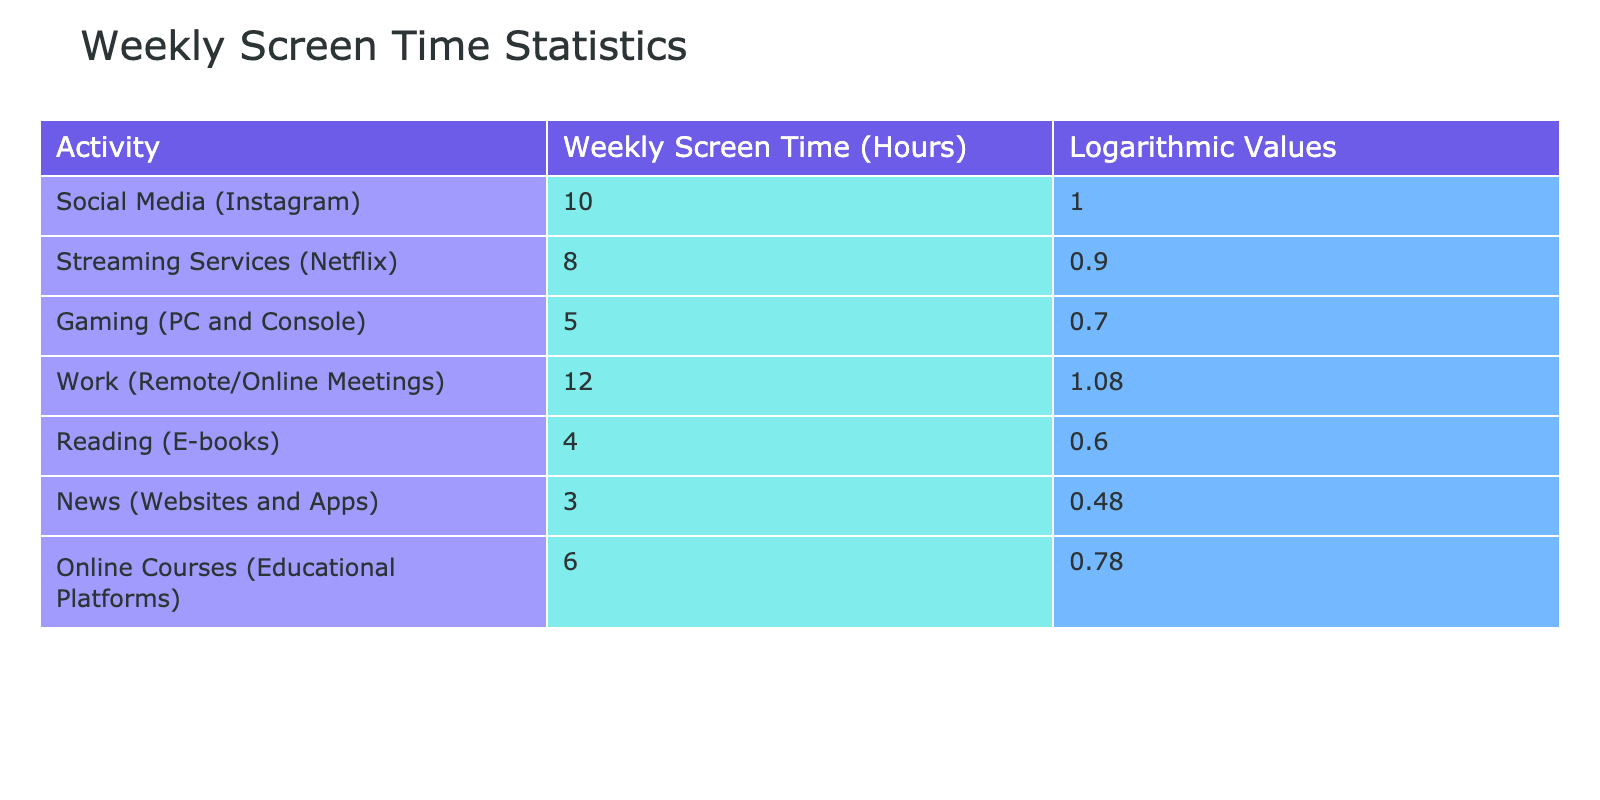What is the weekly screen time for Social Media (Instagram)? The table shows a specific value for each activity, and for Social Media (Instagram), the value listed is 10 hours.
Answer: 10 hours What is the logarithmic value for Streaming Services (Netflix)? By checking the table under the logarithmic values column, we can see that the value listed for Streaming Services (Netflix) is 0.90.
Answer: 0.90 Which activity has the highest weekly screen time? To determine which activity has the highest weekly screen time, we look for the maximum value in the Weekly Screen Time (Hours) column. The highest value is 12 hours for Work (Remote/Online Meetings).
Answer: Work (Remote/Online Meetings) What is the average weekly screen time for reading and news combined? First, find the weekly screen time for Reading (E-books) which is 4 hours, and for News (Websites and Apps) which is 3 hours. Then sum these values: 4 + 3 = 7 hours. Finally, since there are two activities, divide by 2 to find the average: 7 / 2 = 3.5 hours.
Answer: 3.5 hours Is the weekly screen time for Online Courses greater than that for Gaming? The weekly screen time for Online Courses (6 hours) and Gaming (5 hours) is compared. Since 6 is greater than 5, the statement is true.
Answer: Yes What is the total weekly screen time for all activities? To find the total weekly screen time, sum all the values in the Weekly Screen Time (Hours) column: 10 + 8 + 5 + 12 + 4 + 3 + 6 = 48 hours.
Answer: 48 hours Are there more activities with a logarithmic value greater than 0.7 than those with a value less than or equal to 0.7? Count the activities with logarithmic values greater than 0.7, which are Social Media (1.00), Streaming Services (0.90), and Work (1.08) totaling 3 activities. For those with 0.7 or less, we have Gaming (0.70), Reading (0.60), News (0.48), and Online Courses (0.78) totaling 4 activities. Since there are more activities with a value of 0.7 or less, the answer is no.
Answer: No What is the difference in weekly screen time between Work and News? The weekly screen time for Work (Remote/Online Meetings) is 12 hours and for News (Websites and Apps) is 3 hours. To find the difference, subtract the value for News from Work: 12 - 3 = 9 hours.
Answer: 9 hours What is the range of weekly screen time across all activities? To calculate the range, find the maximum (12 hours for Work) and minimum (3 hours for News) values. The range is calculated by subtracting the minimum value from the maximum: 12 - 3 = 9 hours.
Answer: 9 hours 